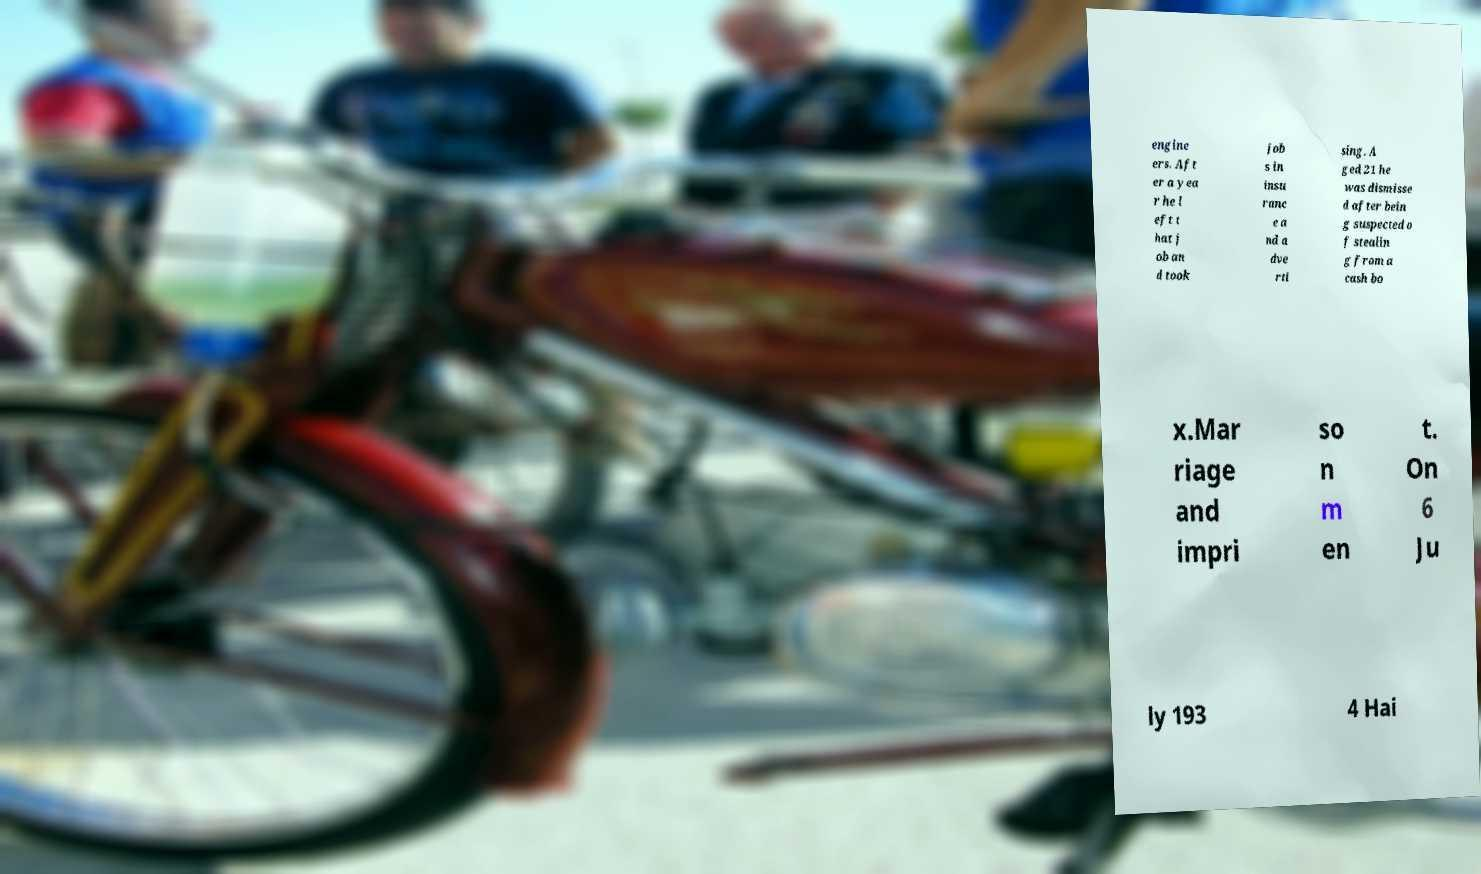Can you read and provide the text displayed in the image?This photo seems to have some interesting text. Can you extract and type it out for me? engine ers. Aft er a yea r he l eft t hat j ob an d took job s in insu ranc e a nd a dve rti sing. A ged 21 he was dismisse d after bein g suspected o f stealin g from a cash bo x.Mar riage and impri so n m en t. On 6 Ju ly 193 4 Hai 